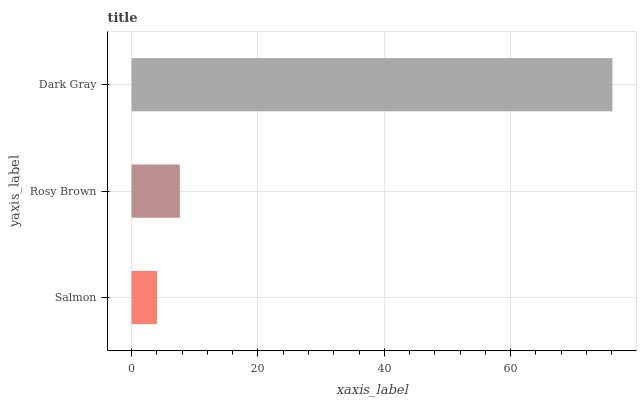Is Salmon the minimum?
Answer yes or no. Yes. Is Dark Gray the maximum?
Answer yes or no. Yes. Is Rosy Brown the minimum?
Answer yes or no. No. Is Rosy Brown the maximum?
Answer yes or no. No. Is Rosy Brown greater than Salmon?
Answer yes or no. Yes. Is Salmon less than Rosy Brown?
Answer yes or no. Yes. Is Salmon greater than Rosy Brown?
Answer yes or no. No. Is Rosy Brown less than Salmon?
Answer yes or no. No. Is Rosy Brown the high median?
Answer yes or no. Yes. Is Rosy Brown the low median?
Answer yes or no. Yes. Is Dark Gray the high median?
Answer yes or no. No. Is Dark Gray the low median?
Answer yes or no. No. 